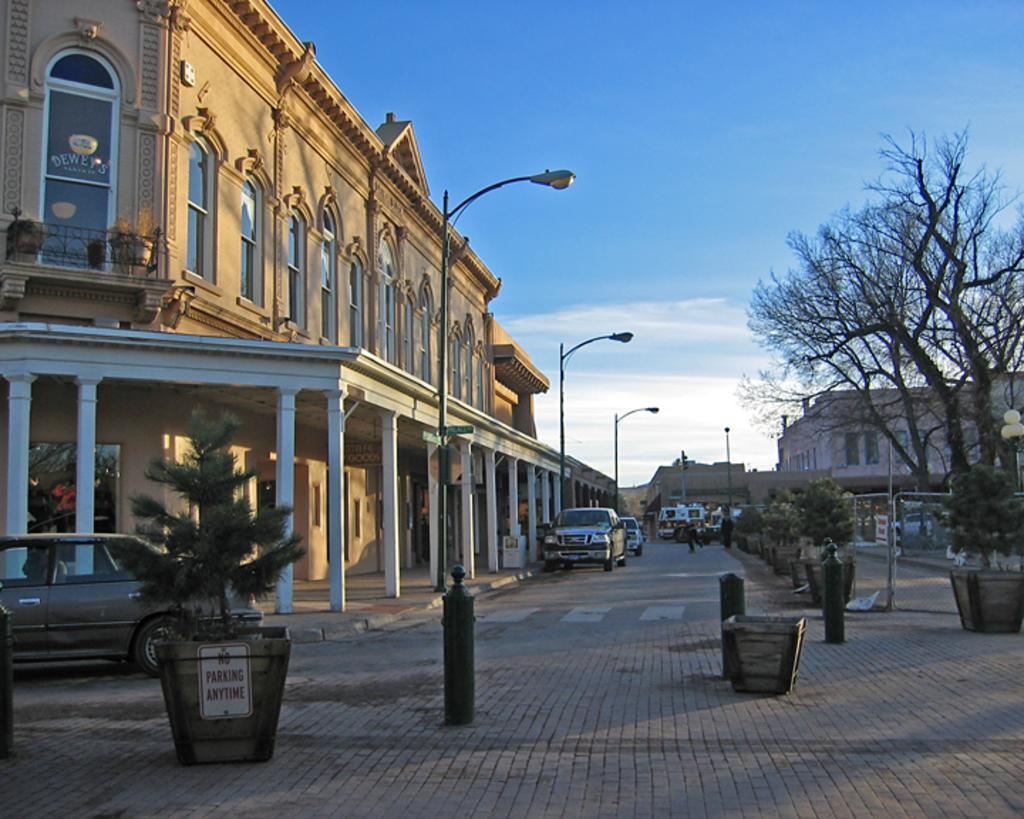Describe this image in one or two sentences. In this picture I can see many buildings. In the center I can see the cars which are parked near to the street lights, poles and plants. On the right I can see the trees. At the top I can see the sky and clouds. 